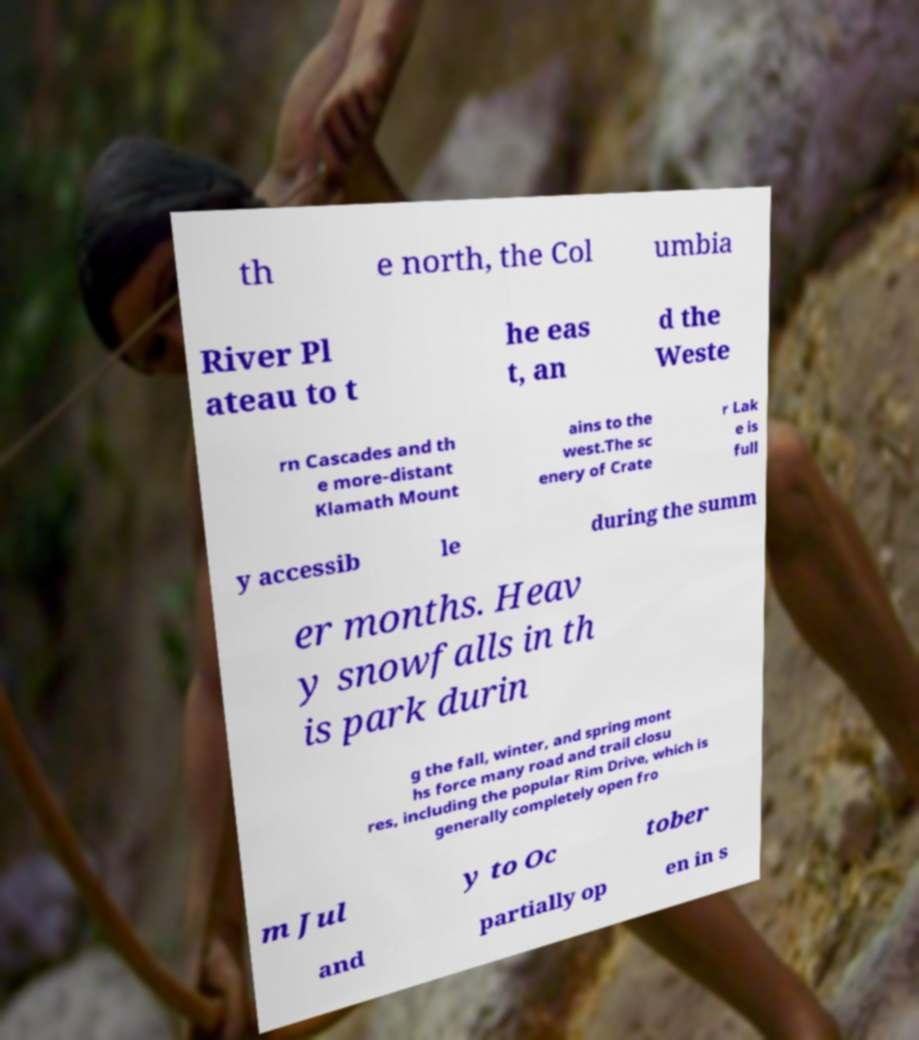There's text embedded in this image that I need extracted. Can you transcribe it verbatim? th e north, the Col umbia River Pl ateau to t he eas t, an d the Weste rn Cascades and th e more-distant Klamath Mount ains to the west.The sc enery of Crate r Lak e is full y accessib le during the summ er months. Heav y snowfalls in th is park durin g the fall, winter, and spring mont hs force many road and trail closu res, including the popular Rim Drive, which is generally completely open fro m Jul y to Oc tober and partially op en in s 